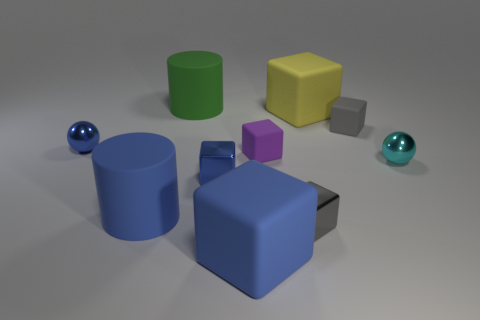Subtract all brown spheres. How many blue blocks are left? 2 Subtract all tiny purple cubes. How many cubes are left? 5 Subtract all cylinders. How many objects are left? 8 Subtract 1 cubes. How many cubes are left? 5 Subtract all blue balls. How many balls are left? 1 Add 5 matte cylinders. How many matte cylinders exist? 7 Subtract 1 green cylinders. How many objects are left? 9 Subtract all brown spheres. Subtract all yellow cylinders. How many spheres are left? 2 Subtract all big yellow rubber blocks. Subtract all small metal things. How many objects are left? 5 Add 3 cylinders. How many cylinders are left? 5 